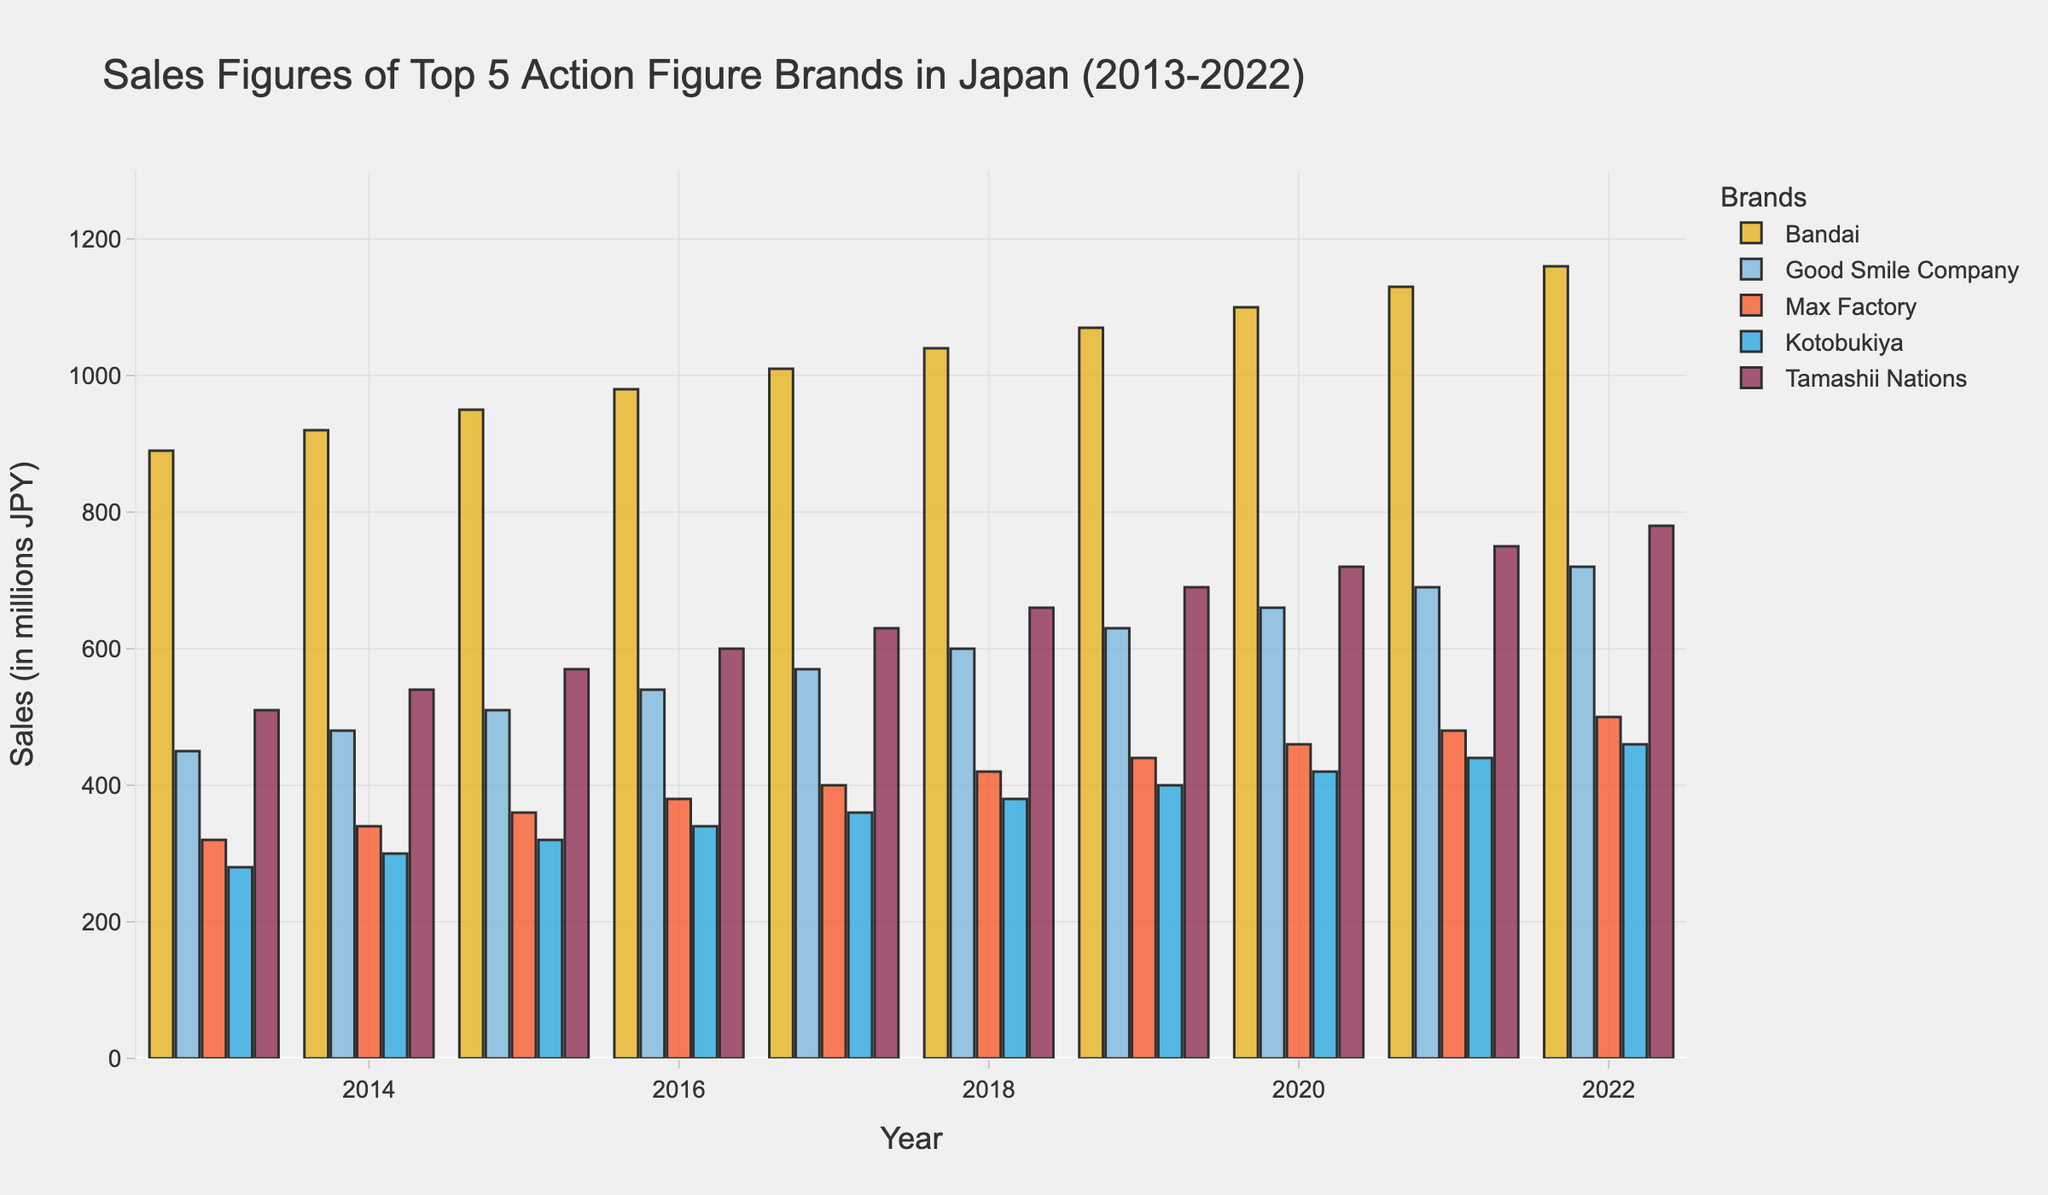What is the trend of sales figures for Bandai from 2013 to 2022? To identify the trend, look at the bar heights for Bandai across all years (2013-2022). The bars increase in height from 2013 (890 million JPY) to 2022 (1160 million JPY), indicating a consistent upward trend in sales.
Answer: The sales figures for Bandai show a consistent upward trend Which brand had the highest sales figure in 2022? Look at the heights of the bars for all brands in the year 2022. The tallest bar represents Bandai with a height corresponding to 1160 million JPY.
Answer: Bandai By how much did Good Smile Company's sales increase from 2016 to 2022? Find the sales figures for Good Smile Company in the years 2016 (540 million JPY) and 2022 (720 million JPY). Subtract the 2016 figure from the 2022 figure: 720 - 540 = 180 million JPY.
Answer: 180 million JPY Which brand experienced the smallest increase in sales from 2013 to 2022? Calculate the sales increase for each brand from 2013 to 2022 and compare. Bandai (1160 - 890 = +270), Good Smile Company (720 - 450 = +270), Max Factory (500 - 320 = +180), Kotobukiya (460 - 280 = +180), Tamashii Nations (780 - 510 = +270). Max Factory and Kotobukiya both have the smallest increase of 180 million JPY.
Answer: Max Factory and Kotobukiya Compare the sales figures of Tamashii Nations and Kotobukiya in 2018. Which brand had higher sales? Look at the bars representing Tamashii Nations and Kotobukiya for the year 2018. Tamashii Nations' bar is taller, corresponding to 660 million JPY, whereas Kotobukiya's bar corresponds to 380 million JPY.
Answer: Tamashii Nations What is the average sales figure for Max Factory over the decade? Add Max Factory's sales figures for each year from 2013 to 2022 and divide by the number of years (10). (320 + 340 + 360 + 380 + 400 + 420 + 440 + 460 + 480 + 500) / 10 = 4100 / 10 = 410 million JPY.
Answer: 410 million JPY Which brand had the most stable sales figures (smallest fluctuation) over the period? To determine the most stable sales figures, observe the bars' heights for each brand across all years. Kotobukiya's bar heights show the least fluctuation, with sales increasing consistently but with smaller increments compared to other brands.
Answer: Kotobukiya In which year did Good Smile Company surpass 600 million JPY in sales? Look through the bar heights for Good Smile Company. The sales exceeded 600 million JPY in 2018, where the bar corresponds to 600 million JPY.
Answer: 2018 What is the total sales of Kotobukiya from 2013 to 2022? Sum up Kotobukiya's sales figures for each year: 280 + 300 + 320 + 340 + 360 + 380 + 400 + 420 + 440 + 460 = 3700 million JPY.
Answer: 3700 million JPY 